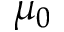Convert formula to latex. <formula><loc_0><loc_0><loc_500><loc_500>\mu _ { 0 }</formula> 